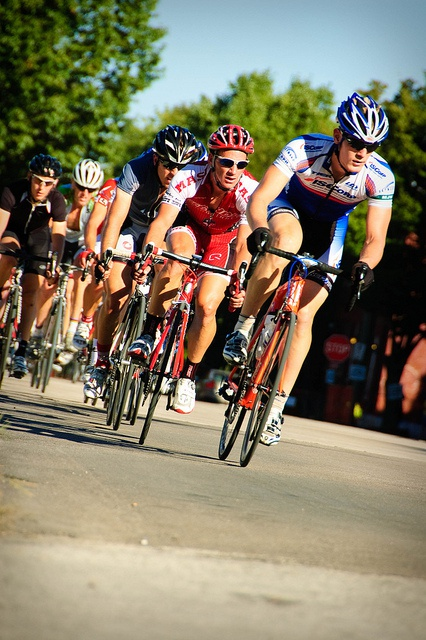Describe the objects in this image and their specific colors. I can see people in black, tan, white, and maroon tones, people in black, maroon, white, and orange tones, people in black, tan, maroon, and ivory tones, bicycle in black, maroon, and gray tones, and people in black, maroon, and tan tones in this image. 